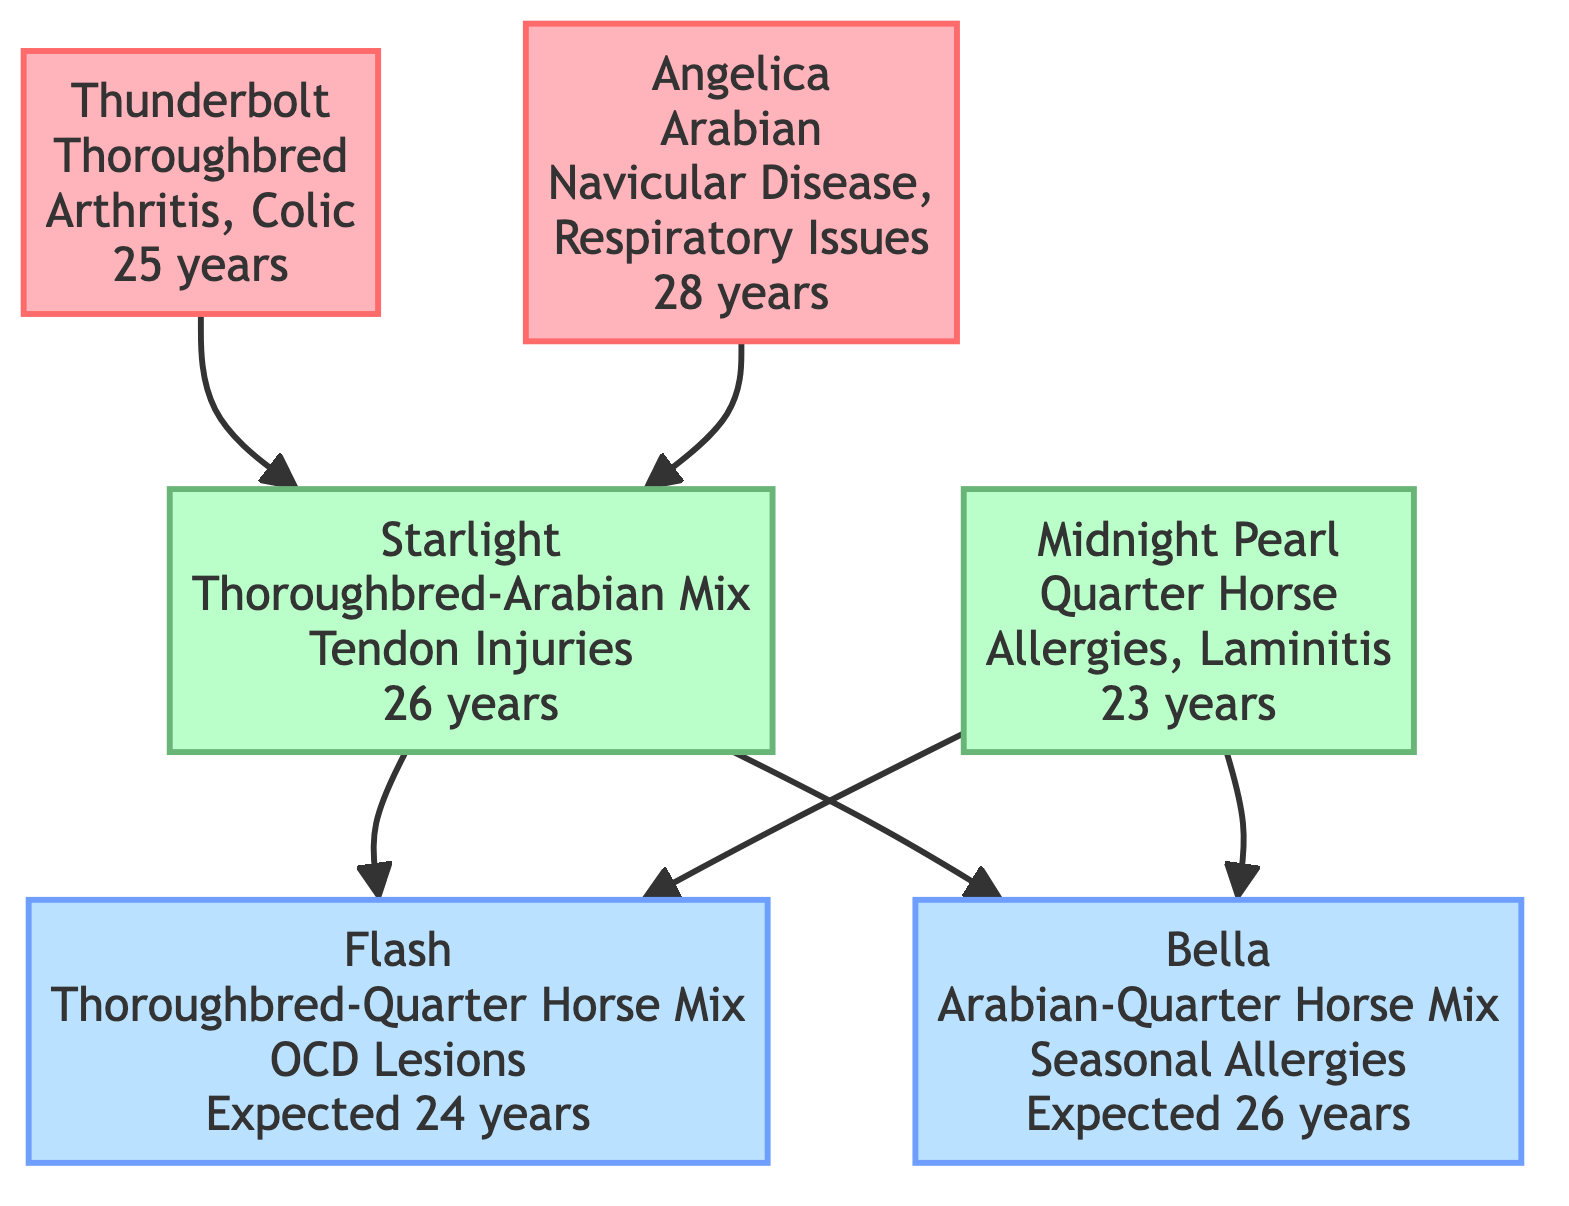What is the breed of Flash? Flash is represented in the diagram as a Thoroughbred-Quarter Horse Mix. This information is directly displayed within the node for Flash.
Answer: Thoroughbred-Quarter Horse Mix How many health conditions does Bella have? Bella's node lists one health condition, which is Seasonal Allergies. This information is explicitly shown in the diagram.
Answer: 1 Which grandparent has the longest lifespan? The lifespans for grandparents are 25 years for Thunderbolt and 28 years for Angelica. By comparing these values, Angelica has the longest lifespan.
Answer: 28 years What health condition is shared between Starlight and Midnight Pearl? Starlight has a health condition of Tendon Injuries, while Midnight Pearl has Allergies and Laminitis. There are no shared health conditions between these two parents in the diagram. Therefore, the answer is that there are no shared health conditions.
Answer: None Which horse has a lifespan expectation of 26 years? Bella’s node indicates that her expected lifespan is 26 years. The response follows directly from the information within Bella's node in the diagram.
Answer: 26 years How is Flash related to Thunderbolt? Flash is the grandson of Thunderbolt. By tracing the family tree, Thunderbolt is the grandparent of Starlight, who is the parent of Flash.
Answer: Grandson What is the breed of Angelica? The node for Angelica displays that her breed is Arabian. This information is provided clearly in the diagram.
Answer: Arabian How many total nodes are there in the diagram? The diagram includes six distinct nodes: two grandparents, two parents, and two current generation horses. Summing these up gives a total of six nodes.
Answer: 6 Which current generation horse has a health condition of OCD Lesions? The node for Flash indicates that he has a health condition of OCD Lesions. This detail is summarized within Flash's node.
Answer: Flash What are the health conditions of Midnight Pearl? Midnight Pearl's node shows that she has Allergies and Laminitis listed as her health conditions. These details can be found in her respective node.
Answer: Allergies, Laminitis 